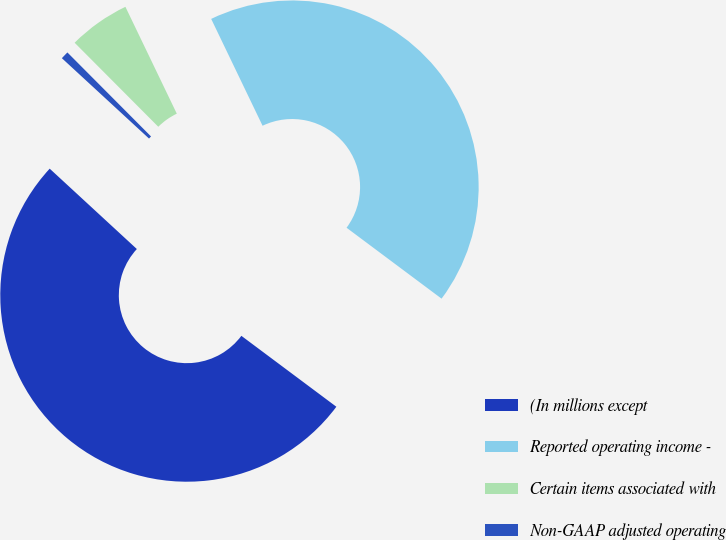<chart> <loc_0><loc_0><loc_500><loc_500><pie_chart><fcel>(In millions except<fcel>Reported operating income -<fcel>Certain items associated with<fcel>Non-GAAP adjusted operating<nl><fcel>51.65%<fcel>42.34%<fcel>5.33%<fcel>0.68%<nl></chart> 